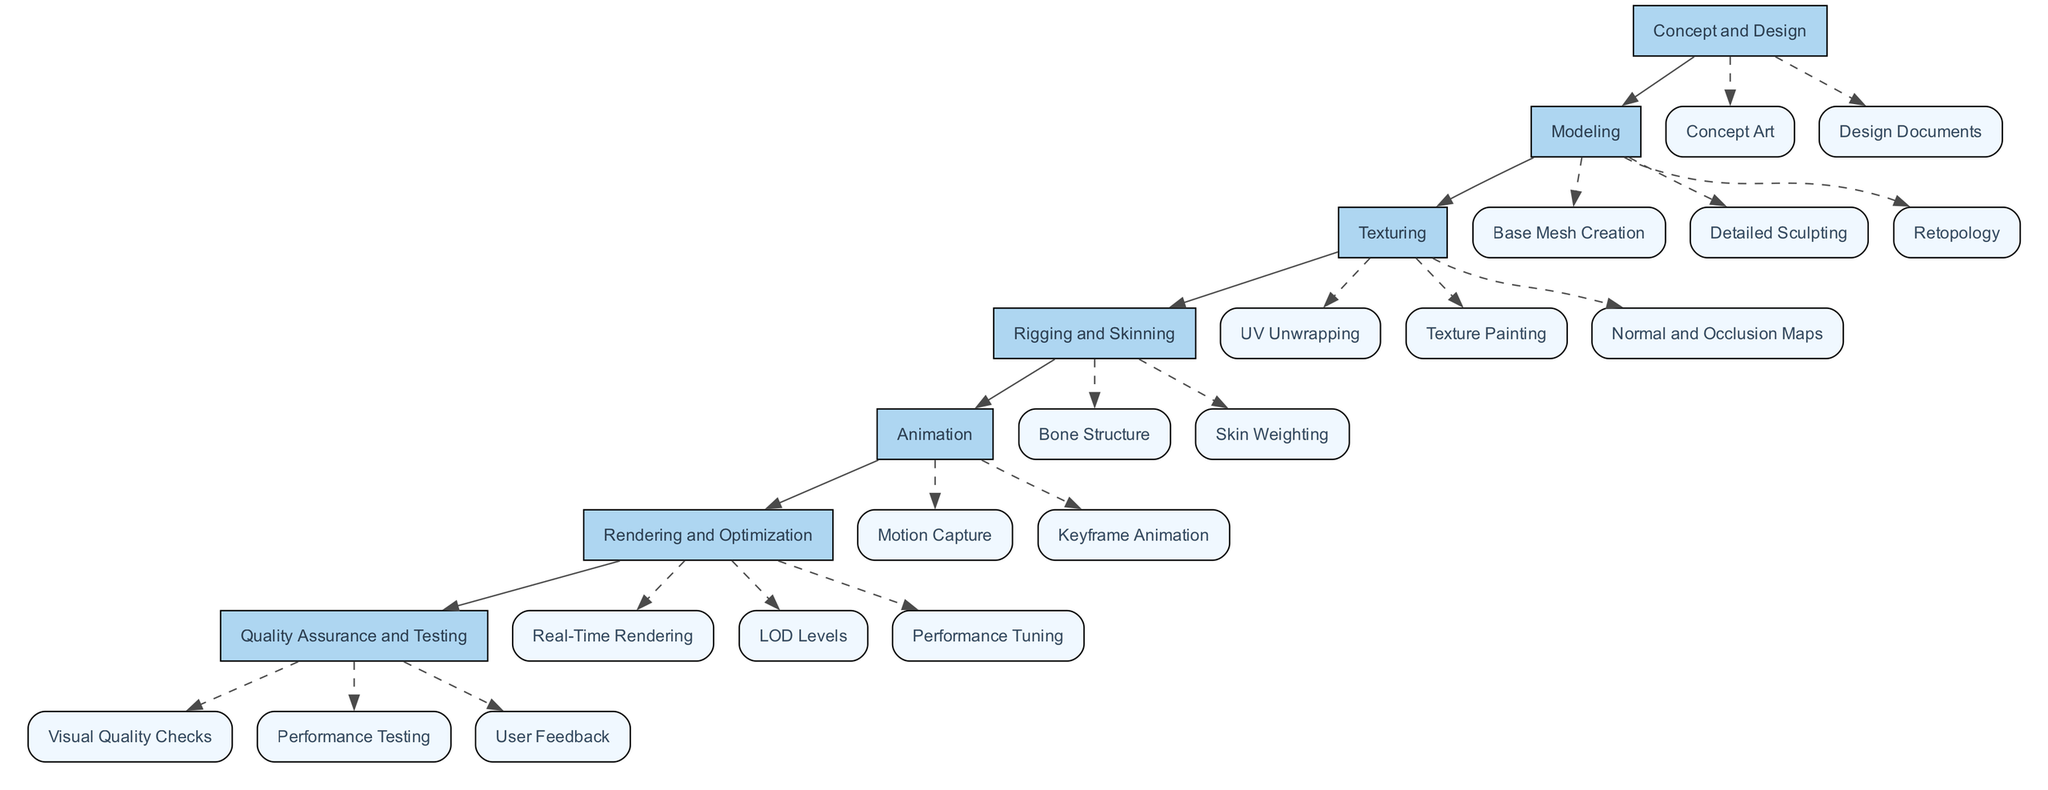What are the main phases in the development process? The main phases are Concept and Design, Modeling, Texturing, Rigging and Skinning, Animation, Rendering and Optimization, Quality Assurance and Testing. Each is represented as a primary node in the diagram.
Answer: Concept and Design, Modeling, Texturing, Rigging and Skinning, Animation, Rendering and Optimization, Quality Assurance and Testing How many sub-steps are in the Texturing phase? The Texturing phase has three specific sub-steps: UV Unwrapping, Texture Painting, and Normal and Occlusion Maps. This count is determined by examining the Texturing node and its connections to sub-nodes.
Answer: 3 Which phase comes directly after Modeling? The phase that comes directly after Modeling is Texturing. This relationship is established by following the flow from the Modeling node to the next connected node in the diagram.
Answer: Texturing What is the last step in the development process? The last step is User Feedback, which falls under Quality Assurance and Testing. This can be found by tracing the final connections from the main phases to their respective sub-steps.
Answer: User Feedback How many nodes are in the Rigging and Skinning phase? The Rigging and Skinning phase consists of two nodes: Bone Structure and Skin Weighting. This is determined by counting the nodes connected to the Rigging and Skinning main phase node in the diagram.
Answer: 2 Which sub-step involves creating the skeleton system for animations? The sub-step that involves creating the skeleton system for animations is Bone Structure. This is found by checking the descriptions associated with the Rigging and Skinning sub-steps in the diagram.
Answer: Bone Structure What type of testing is done after performance testing? The type of testing done after performance testing is User Feedback. This sequence is identified by analyzing the connections between the Quality Assurance and Testing sub-steps.
Answer: User Feedback Which software can be used for detailed sculpting? ZBrush or Mudbox can be used for detailed sculpting. This information is accessed by looking at the description connected to the Detailed Sculpting sub-step under Modeling.
Answer: ZBrush or Mudbox What phase optimizes the mesh for rendering? The phase that optimizes the mesh for rendering is Retopology. This can be found by looking at the sub-steps listed under the Modeling phase for their specific functions.
Answer: Retopology 